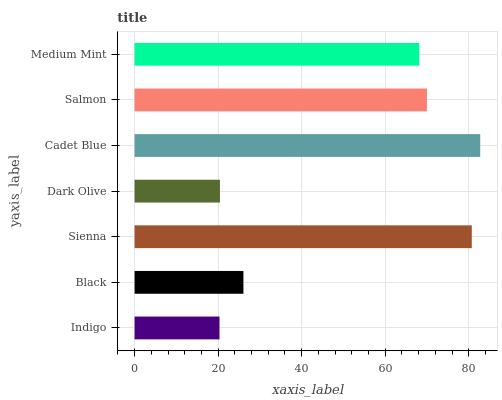Is Indigo the minimum?
Answer yes or no. Yes. Is Cadet Blue the maximum?
Answer yes or no. Yes. Is Black the minimum?
Answer yes or no. No. Is Black the maximum?
Answer yes or no. No. Is Black greater than Indigo?
Answer yes or no. Yes. Is Indigo less than Black?
Answer yes or no. Yes. Is Indigo greater than Black?
Answer yes or no. No. Is Black less than Indigo?
Answer yes or no. No. Is Medium Mint the high median?
Answer yes or no. Yes. Is Medium Mint the low median?
Answer yes or no. Yes. Is Salmon the high median?
Answer yes or no. No. Is Dark Olive the low median?
Answer yes or no. No. 